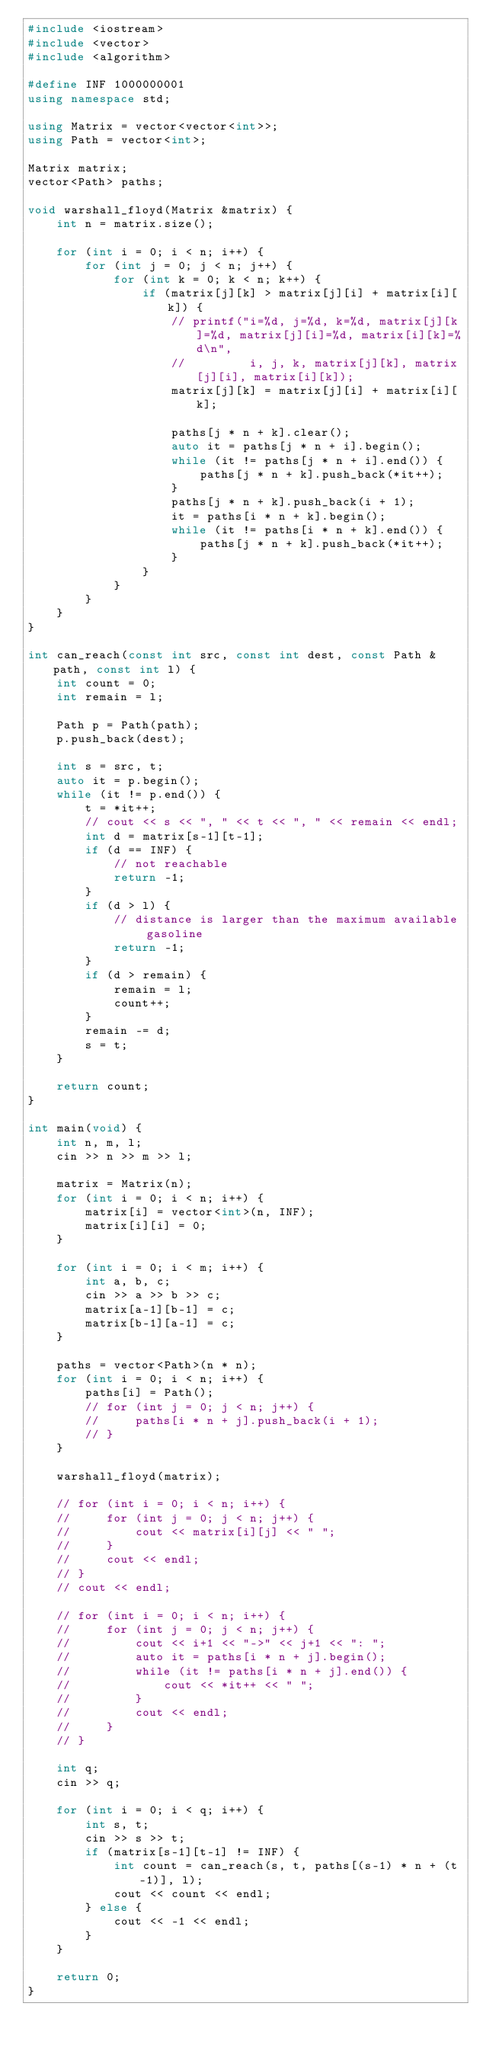<code> <loc_0><loc_0><loc_500><loc_500><_C++_>#include <iostream>
#include <vector>
#include <algorithm>

#define INF 1000000001
using namespace std;

using Matrix = vector<vector<int>>;
using Path = vector<int>;

Matrix matrix;
vector<Path> paths;

void warshall_floyd(Matrix &matrix) {
    int n = matrix.size();

    for (int i = 0; i < n; i++) {
        for (int j = 0; j < n; j++) {
            for (int k = 0; k < n; k++) {
                if (matrix[j][k] > matrix[j][i] + matrix[i][k]) {
                    // printf("i=%d, j=%d, k=%d, matrix[j][k]=%d, matrix[j][i]=%d, matrix[i][k]=%d\n",
                    //         i, j, k, matrix[j][k], matrix[j][i], matrix[i][k]);
                    matrix[j][k] = matrix[j][i] + matrix[i][k];

                    paths[j * n + k].clear();
                    auto it = paths[j * n + i].begin();
                    while (it != paths[j * n + i].end()) {
                        paths[j * n + k].push_back(*it++);
                    }
                    paths[j * n + k].push_back(i + 1);
                    it = paths[i * n + k].begin();
                    while (it != paths[i * n + k].end()) {
                        paths[j * n + k].push_back(*it++);
                    }
                }
            }
        }
    }
}

int can_reach(const int src, const int dest, const Path &path, const int l) {
    int count = 0;
    int remain = l;

    Path p = Path(path);
    p.push_back(dest);

    int s = src, t;
    auto it = p.begin();
    while (it != p.end()) {
        t = *it++;
        // cout << s << ", " << t << ", " << remain << endl;
        int d = matrix[s-1][t-1];
        if (d == INF) {
            // not reachable
            return -1;
        }
        if (d > l) {
            // distance is larger than the maximum available gasoline
            return -1;
        }
        if (d > remain) {
            remain = l;
            count++;
        }
        remain -= d;
        s = t;
    }

    return count;
}

int main(void) {
    int n, m, l;
    cin >> n >> m >> l;

    matrix = Matrix(n);
    for (int i = 0; i < n; i++) {
        matrix[i] = vector<int>(n, INF);
        matrix[i][i] = 0;
    }

    for (int i = 0; i < m; i++) {
        int a, b, c;
        cin >> a >> b >> c;
        matrix[a-1][b-1] = c;
        matrix[b-1][a-1] = c;
    }

    paths = vector<Path>(n * n);
    for (int i = 0; i < n; i++) {
        paths[i] = Path();
        // for (int j = 0; j < n; j++) {
        //     paths[i * n + j].push_back(i + 1);
        // }
    }

    warshall_floyd(matrix);

    // for (int i = 0; i < n; i++) {
    //     for (int j = 0; j < n; j++) {
    //         cout << matrix[i][j] << " ";
    //     }
    //     cout << endl;
    // }
    // cout << endl;

    // for (int i = 0; i < n; i++) {
    //     for (int j = 0; j < n; j++) {
    //         cout << i+1 << "->" << j+1 << ": ";
    //         auto it = paths[i * n + j].begin();
    //         while (it != paths[i * n + j].end()) {
    //             cout << *it++ << " ";
    //         }
    //         cout << endl;
    //     }
    // }

    int q;
    cin >> q;

    for (int i = 0; i < q; i++) {
        int s, t;
        cin >> s >> t;
        if (matrix[s-1][t-1] != INF) {
            int count = can_reach(s, t, paths[(s-1) * n + (t-1)], l);
            cout << count << endl;
        } else {
            cout << -1 << endl;
        }
    }

    return 0;
}
</code> 